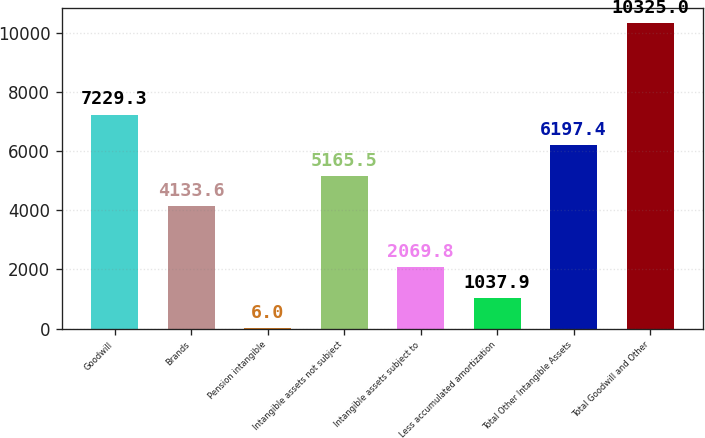Convert chart to OTSL. <chart><loc_0><loc_0><loc_500><loc_500><bar_chart><fcel>Goodwill<fcel>Brands<fcel>Pension intangible<fcel>Intangible assets not subject<fcel>Intangible assets subject to<fcel>Less accumulated amortization<fcel>Total Other Intangible Assets<fcel>Total Goodwill and Other<nl><fcel>7229.3<fcel>4133.6<fcel>6<fcel>5165.5<fcel>2069.8<fcel>1037.9<fcel>6197.4<fcel>10325<nl></chart> 